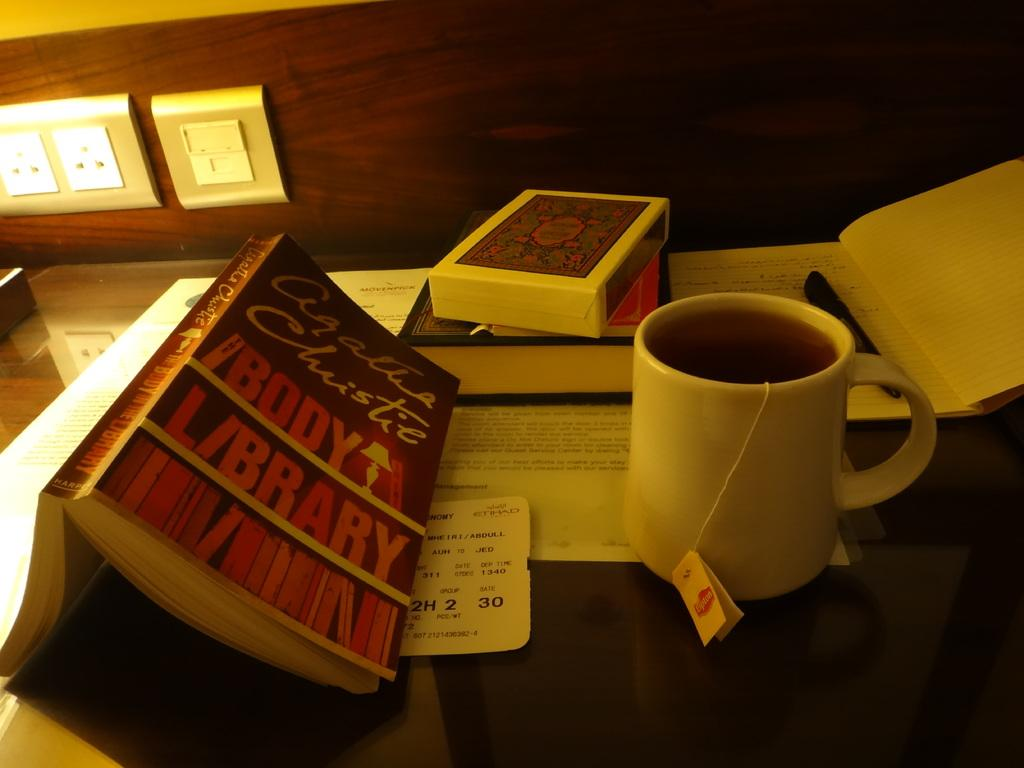What is the main piece of furniture in the image? There is a table in the image. What items can be seen on the table? There are books, a box, a tea mug, and a pen on the table. Is there anything on the wall in the background? Yes, there is a switch board on the wall in the background. How many switches are attached to the wall? One switch is attached to the wall. What emotion is the pig displaying in the image? There is no pig present in the image, so it is not possible to determine the emotion it might be displaying. 